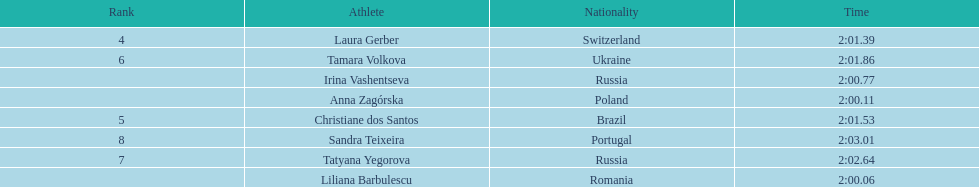In regards to anna zagorska, what was her finishing time? 2:00.11. 